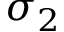Convert formula to latex. <formula><loc_0><loc_0><loc_500><loc_500>\sigma _ { 2 }</formula> 